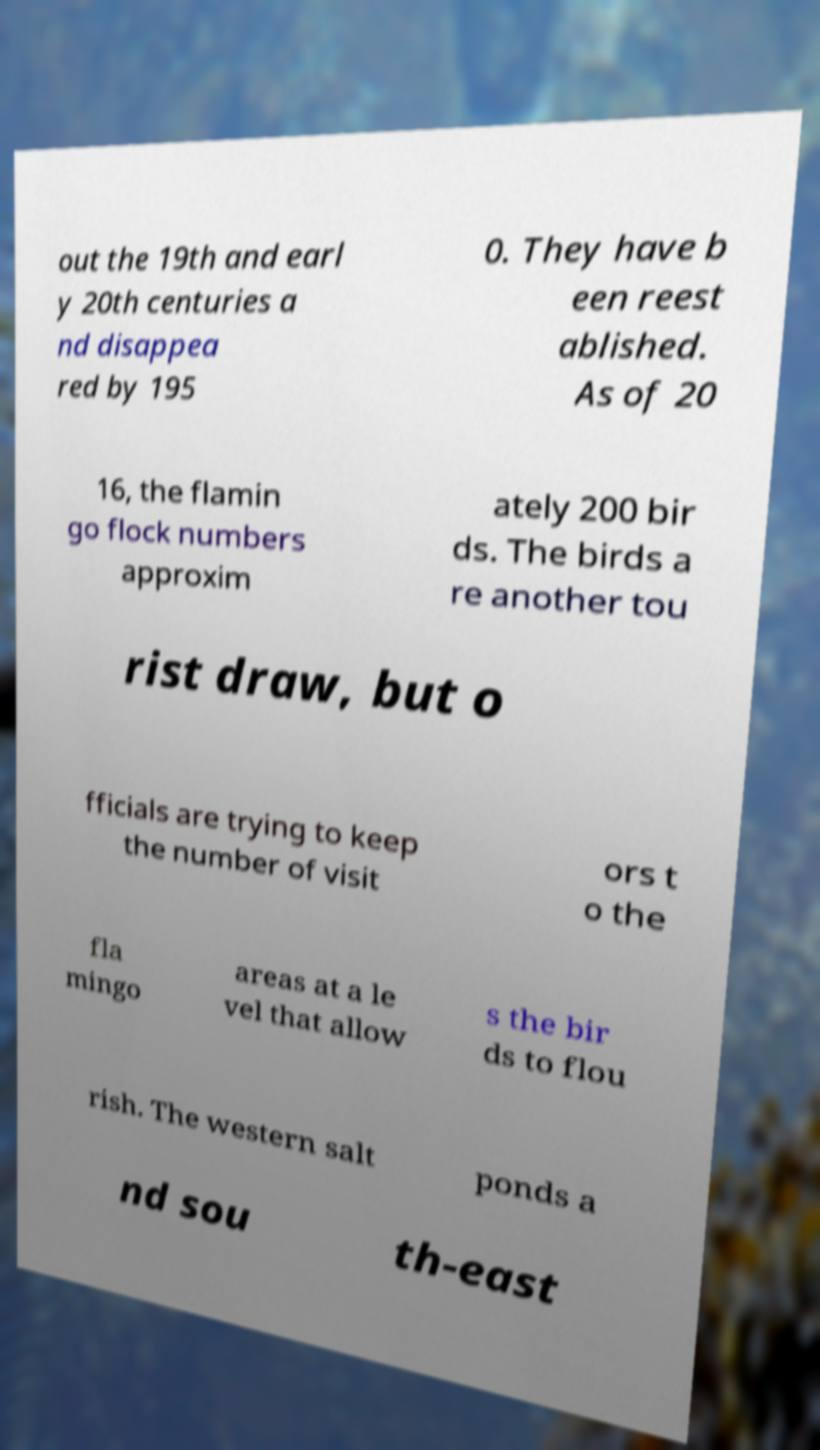I need the written content from this picture converted into text. Can you do that? out the 19th and earl y 20th centuries a nd disappea red by 195 0. They have b een reest ablished. As of 20 16, the flamin go flock numbers approxim ately 200 bir ds. The birds a re another tou rist draw, but o fficials are trying to keep the number of visit ors t o the fla mingo areas at a le vel that allow s the bir ds to flou rish. The western salt ponds a nd sou th-east 